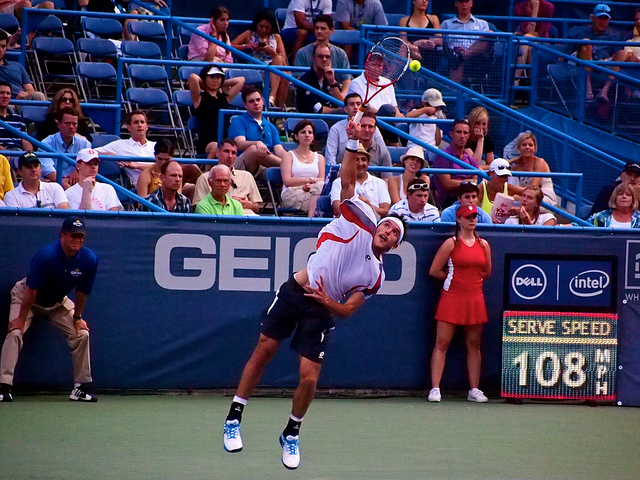<image>What is the speed of the serve? It is unknown what the exact speed of the serve is. It can be either 108 mph or 90 mph. What is the speed of the serve? The speed of the serve is 108 mph. 